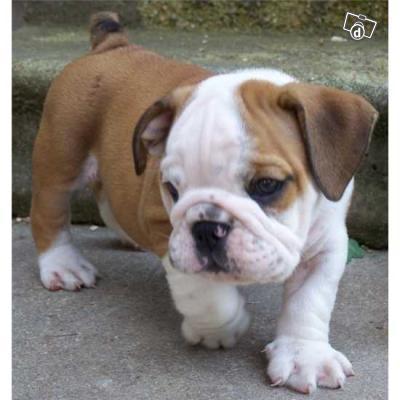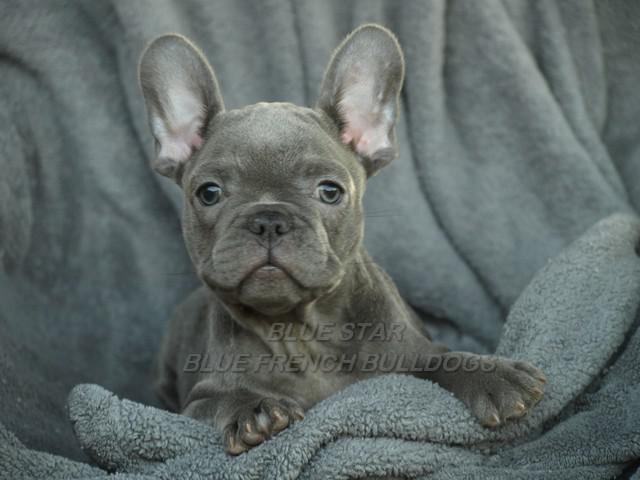The first image is the image on the left, the second image is the image on the right. Considering the images on both sides, is "The dog in the image on the right is outside." valid? Answer yes or no. No. The first image is the image on the left, the second image is the image on the right. Examine the images to the left and right. Is the description "All of the dogs are charcoal gray, with at most a patch of white on the chest, and all dogs have blue eyes." accurate? Answer yes or no. No. 